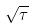Convert formula to latex. <formula><loc_0><loc_0><loc_500><loc_500>\sqrt { \tau }</formula> 